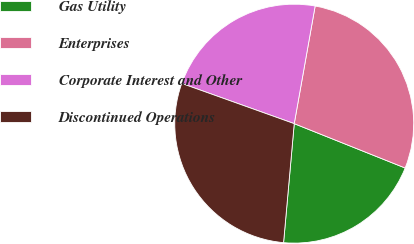Convert chart to OTSL. <chart><loc_0><loc_0><loc_500><loc_500><pie_chart><fcel>Gas Utility<fcel>Enterprises<fcel>Corporate Interest and Other<fcel>Discontinued Operations<nl><fcel>20.37%<fcel>28.25%<fcel>22.34%<fcel>29.04%<nl></chart> 